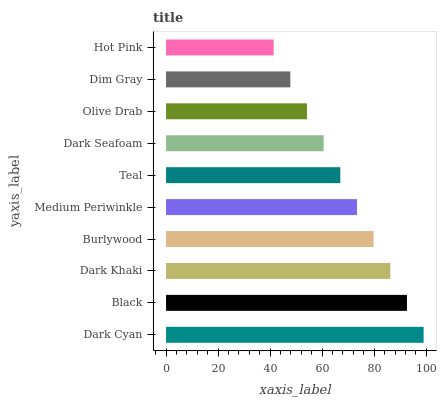Is Hot Pink the minimum?
Answer yes or no. Yes. Is Dark Cyan the maximum?
Answer yes or no. Yes. Is Black the minimum?
Answer yes or no. No. Is Black the maximum?
Answer yes or no. No. Is Dark Cyan greater than Black?
Answer yes or no. Yes. Is Black less than Dark Cyan?
Answer yes or no. Yes. Is Black greater than Dark Cyan?
Answer yes or no. No. Is Dark Cyan less than Black?
Answer yes or no. No. Is Medium Periwinkle the high median?
Answer yes or no. Yes. Is Teal the low median?
Answer yes or no. Yes. Is Dim Gray the high median?
Answer yes or no. No. Is Dark Khaki the low median?
Answer yes or no. No. 